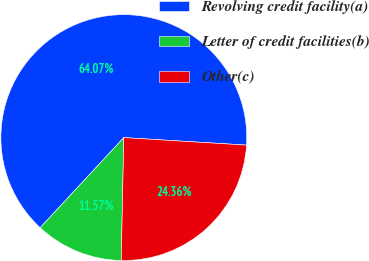Convert chart. <chart><loc_0><loc_0><loc_500><loc_500><pie_chart><fcel>Revolving credit facility(a)<fcel>Letter of credit facilities(b)<fcel>Other(c)<nl><fcel>64.07%<fcel>11.57%<fcel>24.36%<nl></chart> 